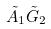Convert formula to latex. <formula><loc_0><loc_0><loc_500><loc_500>\tilde { A } _ { 1 } \tilde { G } _ { 2 }</formula> 